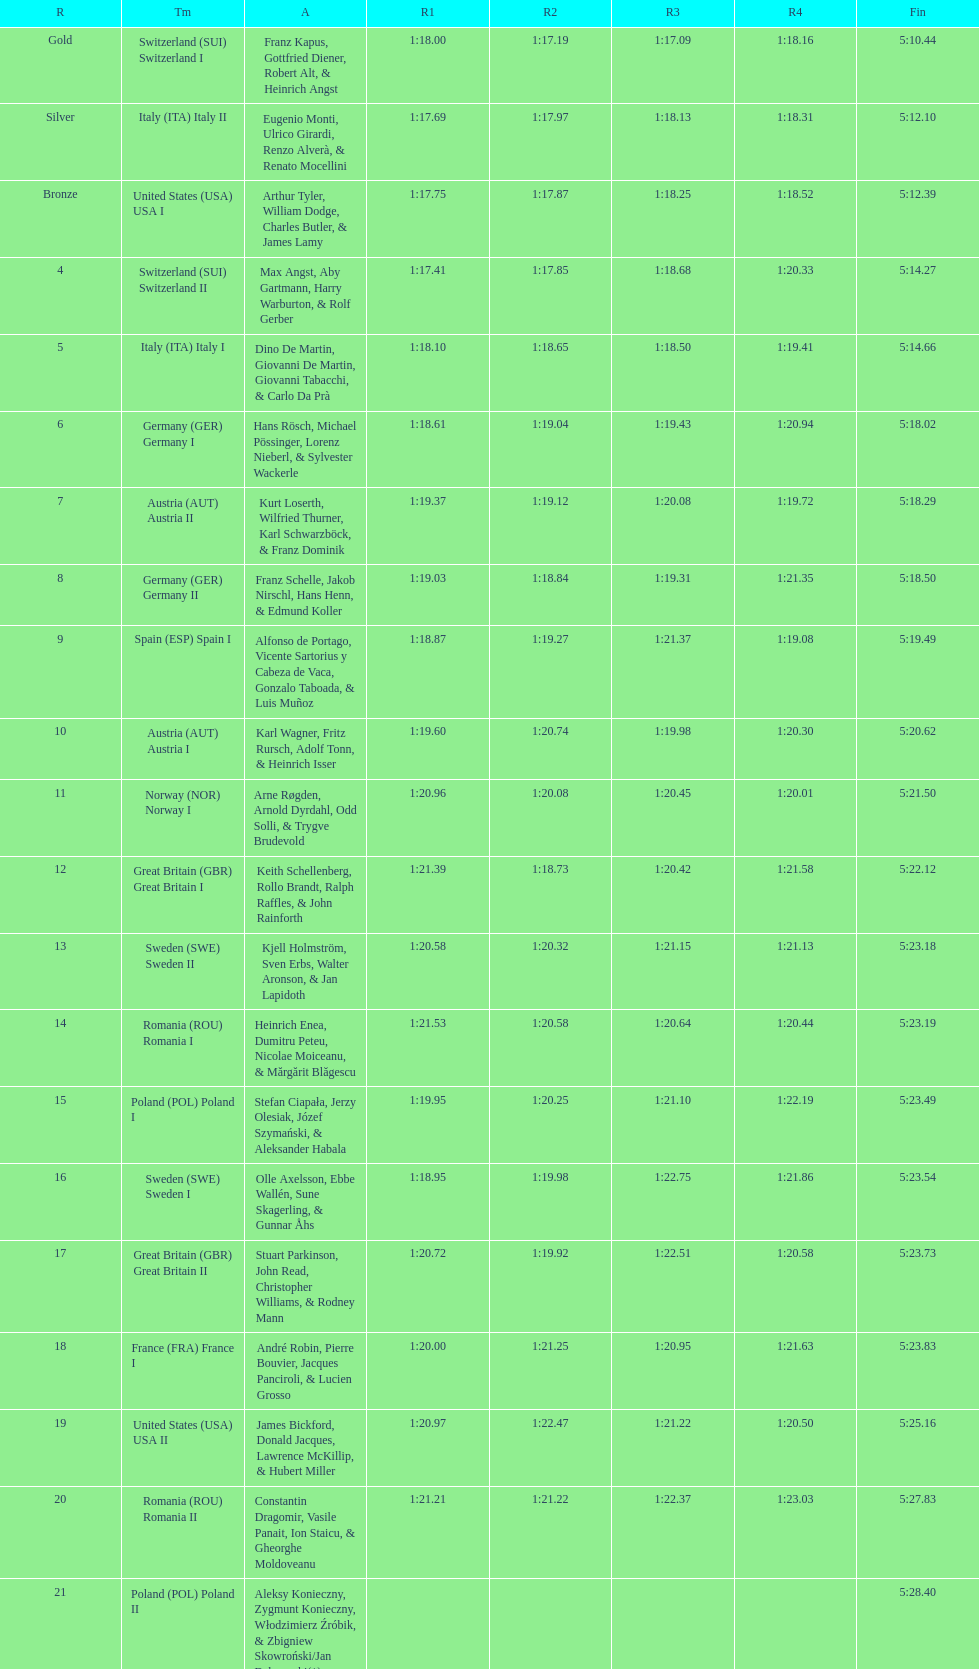What is the team that comes after italy (ita) italy i? Germany I. 